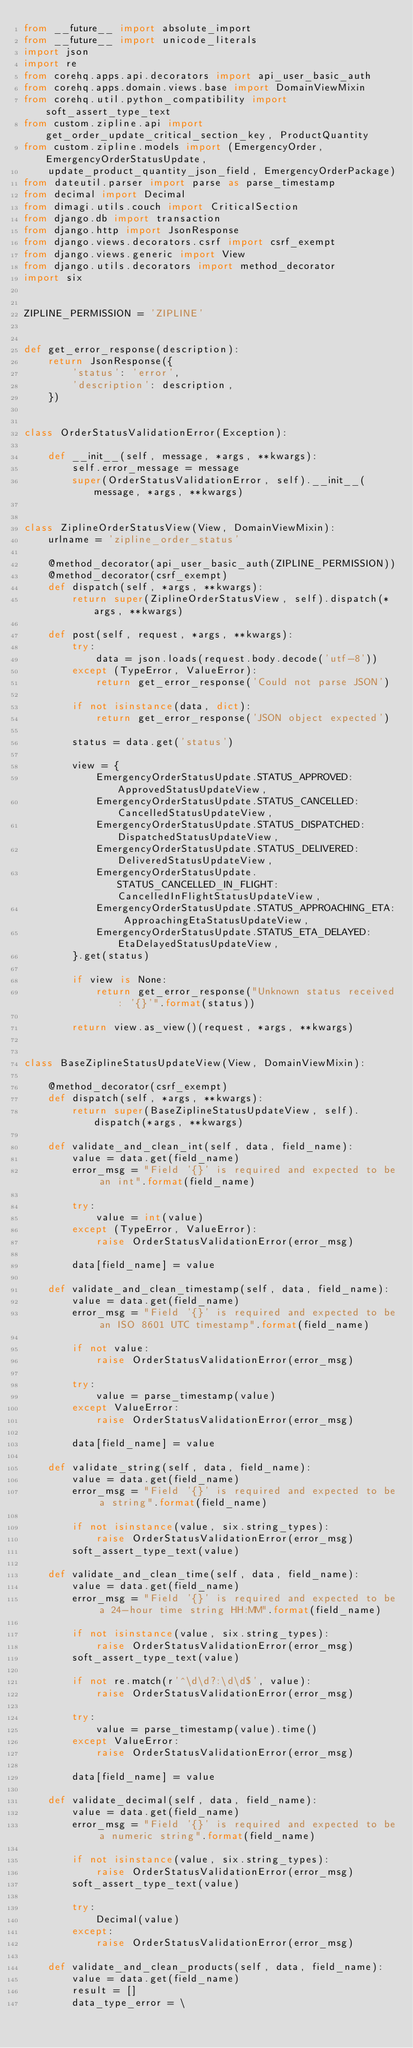<code> <loc_0><loc_0><loc_500><loc_500><_Python_>from __future__ import absolute_import
from __future__ import unicode_literals
import json
import re
from corehq.apps.api.decorators import api_user_basic_auth
from corehq.apps.domain.views.base import DomainViewMixin
from corehq.util.python_compatibility import soft_assert_type_text
from custom.zipline.api import get_order_update_critical_section_key, ProductQuantity
from custom.zipline.models import (EmergencyOrder, EmergencyOrderStatusUpdate,
    update_product_quantity_json_field, EmergencyOrderPackage)
from dateutil.parser import parse as parse_timestamp
from decimal import Decimal
from dimagi.utils.couch import CriticalSection
from django.db import transaction
from django.http import JsonResponse
from django.views.decorators.csrf import csrf_exempt
from django.views.generic import View
from django.utils.decorators import method_decorator
import six


ZIPLINE_PERMISSION = 'ZIPLINE'


def get_error_response(description):
    return JsonResponse({
        'status': 'error',
        'description': description,
    })


class OrderStatusValidationError(Exception):

    def __init__(self, message, *args, **kwargs):
        self.error_message = message
        super(OrderStatusValidationError, self).__init__(message, *args, **kwargs)


class ZiplineOrderStatusView(View, DomainViewMixin):
    urlname = 'zipline_order_status'

    @method_decorator(api_user_basic_auth(ZIPLINE_PERMISSION))
    @method_decorator(csrf_exempt)
    def dispatch(self, *args, **kwargs):
        return super(ZiplineOrderStatusView, self).dispatch(*args, **kwargs)

    def post(self, request, *args, **kwargs):
        try:
            data = json.loads(request.body.decode('utf-8'))
        except (TypeError, ValueError):
            return get_error_response('Could not parse JSON')

        if not isinstance(data, dict):
            return get_error_response('JSON object expected')

        status = data.get('status')

        view = {
            EmergencyOrderStatusUpdate.STATUS_APPROVED: ApprovedStatusUpdateView,
            EmergencyOrderStatusUpdate.STATUS_CANCELLED: CancelledStatusUpdateView,
            EmergencyOrderStatusUpdate.STATUS_DISPATCHED: DispatchedStatusUpdateView,
            EmergencyOrderStatusUpdate.STATUS_DELIVERED: DeliveredStatusUpdateView,
            EmergencyOrderStatusUpdate.STATUS_CANCELLED_IN_FLIGHT: CancelledInFlightStatusUpdateView,
            EmergencyOrderStatusUpdate.STATUS_APPROACHING_ETA: ApproachingEtaStatusUpdateView,
            EmergencyOrderStatusUpdate.STATUS_ETA_DELAYED: EtaDelayedStatusUpdateView,
        }.get(status)

        if view is None:
            return get_error_response("Unknown status received: '{}'".format(status))

        return view.as_view()(request, *args, **kwargs)


class BaseZiplineStatusUpdateView(View, DomainViewMixin):

    @method_decorator(csrf_exempt)
    def dispatch(self, *args, **kwargs):
        return super(BaseZiplineStatusUpdateView, self).dispatch(*args, **kwargs)

    def validate_and_clean_int(self, data, field_name):
        value = data.get(field_name)
        error_msg = "Field '{}' is required and expected to be an int".format(field_name)

        try:
            value = int(value)
        except (TypeError, ValueError):
            raise OrderStatusValidationError(error_msg)

        data[field_name] = value

    def validate_and_clean_timestamp(self, data, field_name):
        value = data.get(field_name)
        error_msg = "Field '{}' is required and expected to be an ISO 8601 UTC timestamp".format(field_name)

        if not value:
            raise OrderStatusValidationError(error_msg)

        try:
            value = parse_timestamp(value)
        except ValueError:
            raise OrderStatusValidationError(error_msg)

        data[field_name] = value

    def validate_string(self, data, field_name):
        value = data.get(field_name)
        error_msg = "Field '{}' is required and expected to be a string".format(field_name)

        if not isinstance(value, six.string_types):
            raise OrderStatusValidationError(error_msg)
        soft_assert_type_text(value)

    def validate_and_clean_time(self, data, field_name):
        value = data.get(field_name)
        error_msg = "Field '{}' is required and expected to be a 24-hour time string HH:MM".format(field_name)

        if not isinstance(value, six.string_types):
            raise OrderStatusValidationError(error_msg)
        soft_assert_type_text(value)

        if not re.match(r'^\d\d?:\d\d$', value):
            raise OrderStatusValidationError(error_msg)

        try:
            value = parse_timestamp(value).time()
        except ValueError:
            raise OrderStatusValidationError(error_msg)

        data[field_name] = value

    def validate_decimal(self, data, field_name):
        value = data.get(field_name)
        error_msg = "Field '{}' is required and expected to be a numeric string".format(field_name)

        if not isinstance(value, six.string_types):
            raise OrderStatusValidationError(error_msg)
        soft_assert_type_text(value)

        try:
            Decimal(value)
        except:
            raise OrderStatusValidationError(error_msg)

    def validate_and_clean_products(self, data, field_name):
        value = data.get(field_name)
        result = []
        data_type_error = \</code> 